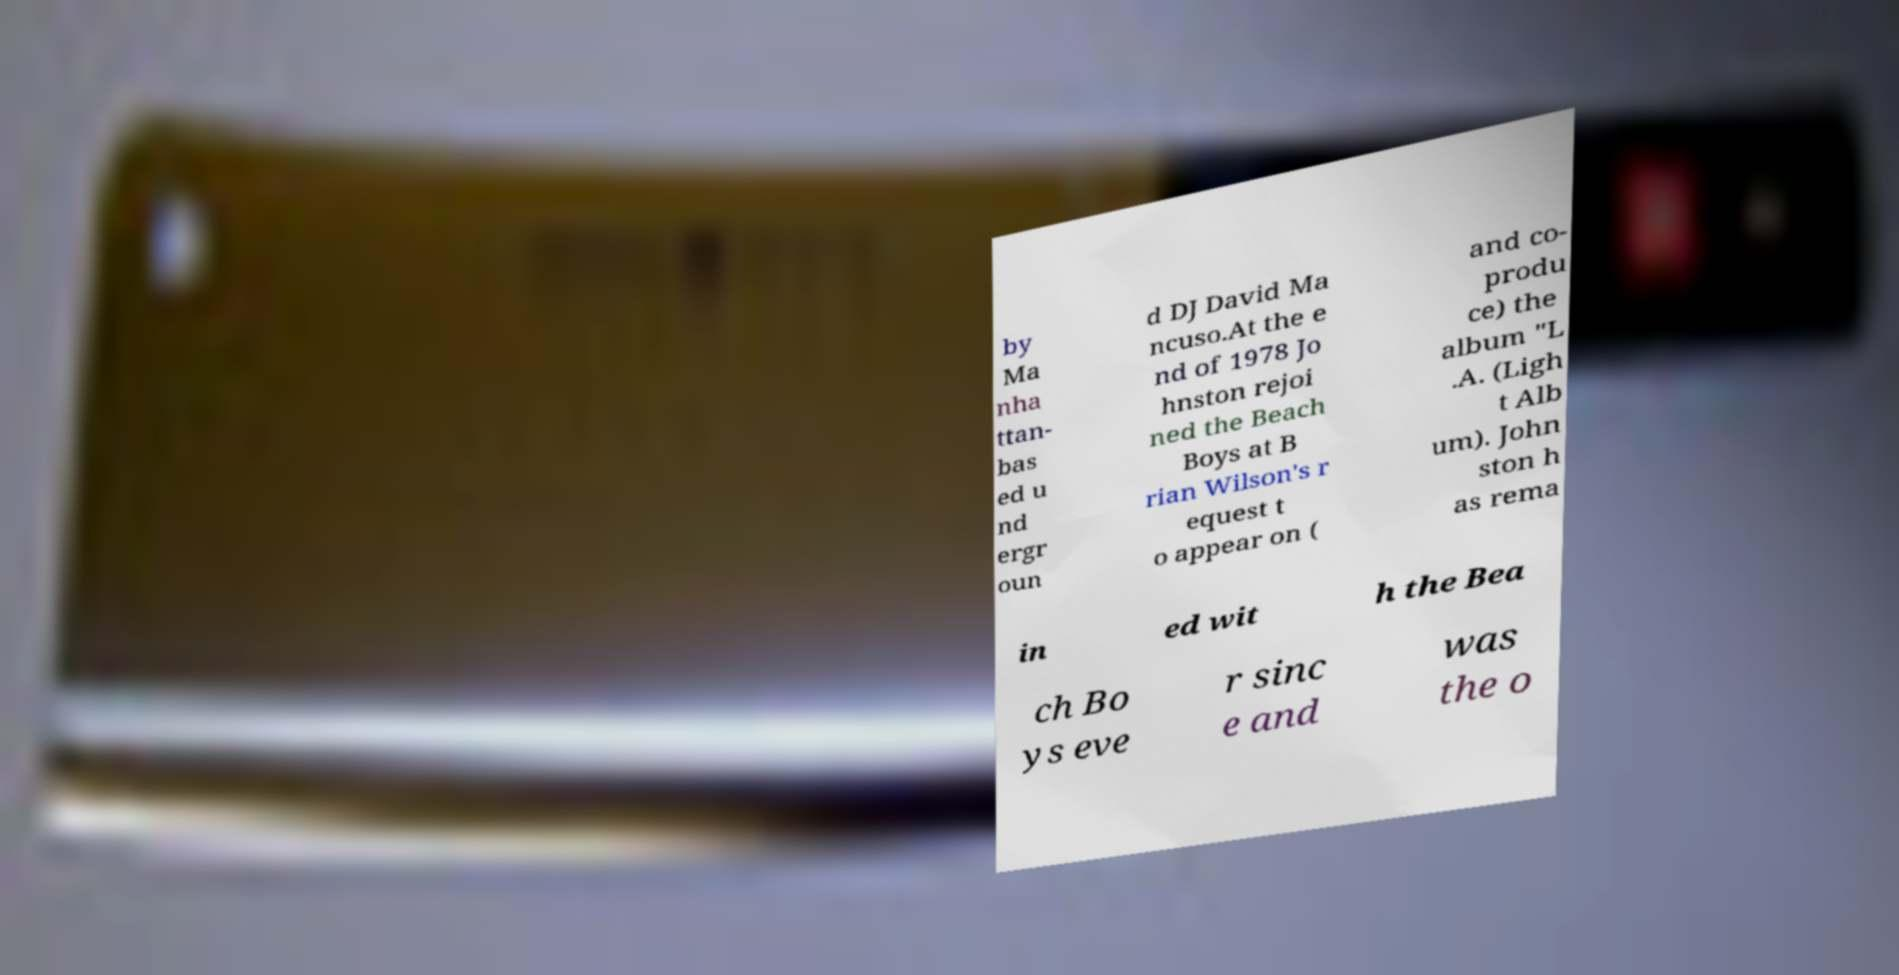There's text embedded in this image that I need extracted. Can you transcribe it verbatim? by Ma nha ttan- bas ed u nd ergr oun d DJ David Ma ncuso.At the e nd of 1978 Jo hnston rejoi ned the Beach Boys at B rian Wilson's r equest t o appear on ( and co- produ ce) the album "L .A. (Ligh t Alb um). John ston h as rema in ed wit h the Bea ch Bo ys eve r sinc e and was the o 